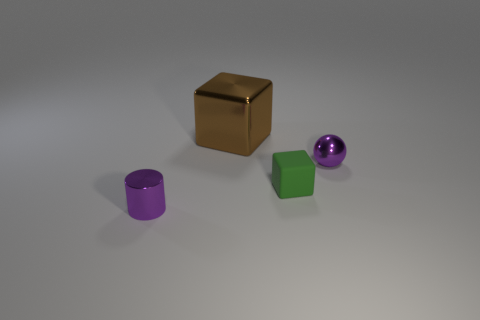Add 3 big brown things. How many objects exist? 7 Subtract all cylinders. How many objects are left? 3 Subtract all brown shiny objects. Subtract all metallic spheres. How many objects are left? 2 Add 1 small purple shiny things. How many small purple shiny things are left? 3 Add 2 small yellow rubber cylinders. How many small yellow rubber cylinders exist? 2 Subtract 0 purple cubes. How many objects are left? 4 